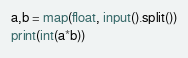Convert code to text. <code><loc_0><loc_0><loc_500><loc_500><_Python_>a,b = map(float, input().split())
print(int(a*b))</code> 